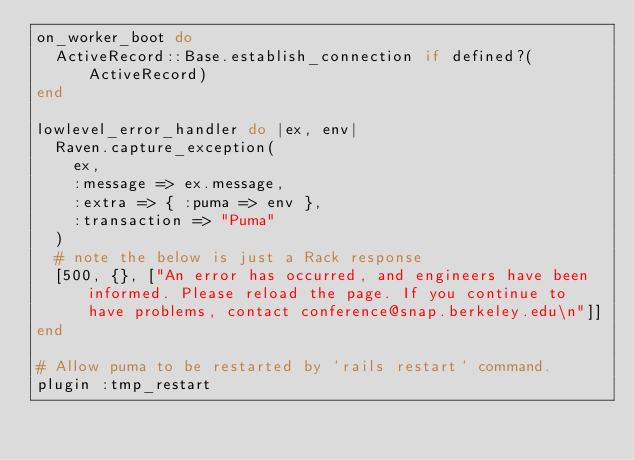Convert code to text. <code><loc_0><loc_0><loc_500><loc_500><_Ruby_>on_worker_boot do
  ActiveRecord::Base.establish_connection if defined?(ActiveRecord)
end

lowlevel_error_handler do |ex, env|
  Raven.capture_exception(
    ex,
    :message => ex.message,
    :extra => { :puma => env },
    :transaction => "Puma"
  )
  # note the below is just a Rack response
  [500, {}, ["An error has occurred, and engineers have been informed. Please reload the page. If you continue to have problems, contact conference@snap.berkeley.edu\n"]]
end

# Allow puma to be restarted by `rails restart` command.
plugin :tmp_restart
</code> 